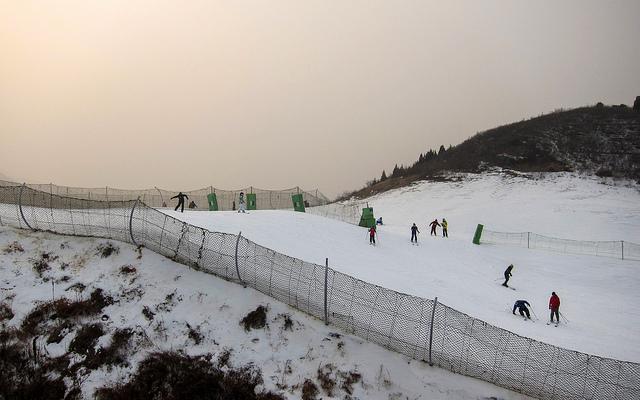What are the people doing?
Answer briefly. Skiing. How many people are in this scene?
Answer briefly. 9. Where was this taken?
Give a very brief answer. Ski resort. Are the people in a fence?
Write a very short answer. Yes. Is this a skate park?
Give a very brief answer. No. 